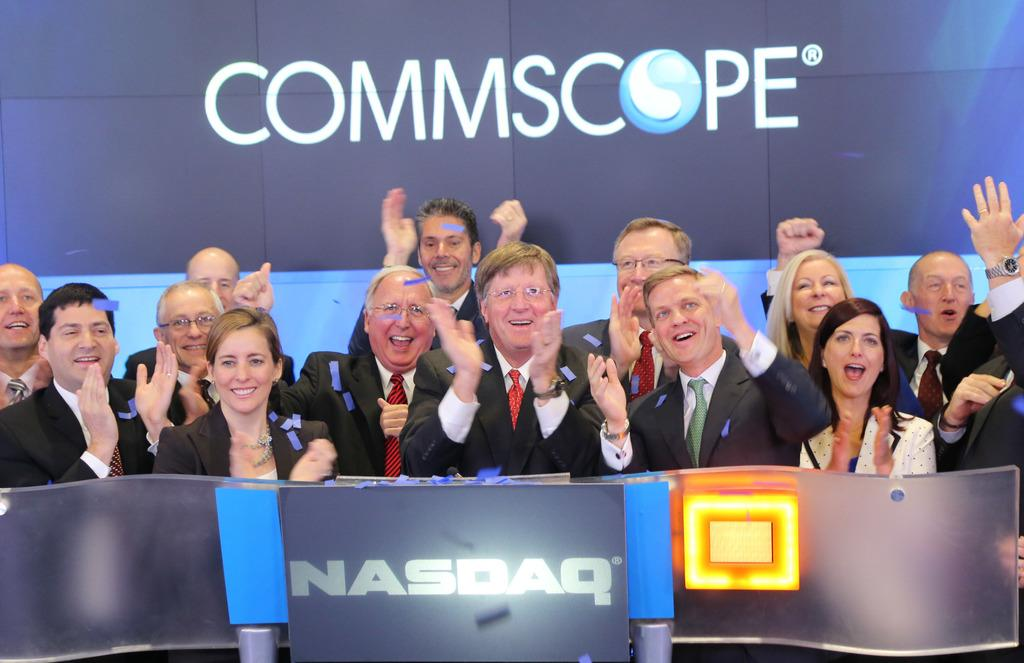What types of people are in the image? There are men and women in the image. What are the people doing in the image? The people are smiling and clapping. What are the people wearing in the image? The people are wearing coats. What is in front of the people in the image? There is a glass table in front of the people. What is behind the people in the image? There is a board present behind the people. What type of honey is being served on the glass table in the image? There is no honey present in the image; it features people wearing coats, smiling, and clapping, with a glass table and a board in the background. 